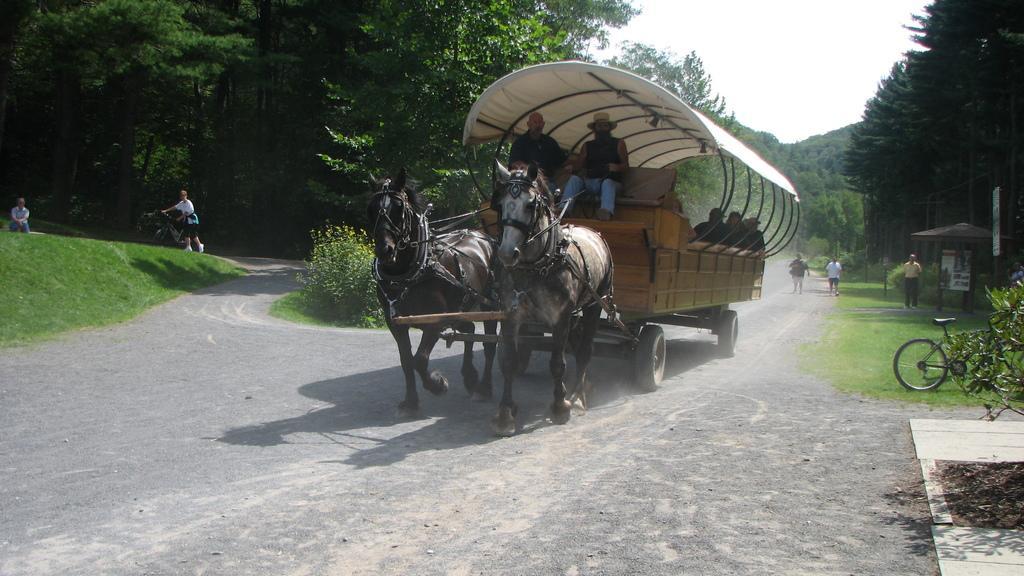Could you give a brief overview of what you see in this image? In this image there is the sky, there are trees truncated towards the right of the image, there are trees truncated towards the left of the image, there is road, there are people on the road, there are bicycles, there is a person sitting towards the left of the image, there is grass truncated towards the left of the image, there is a tonga, there are people sitting on the tonga, there are boards. 